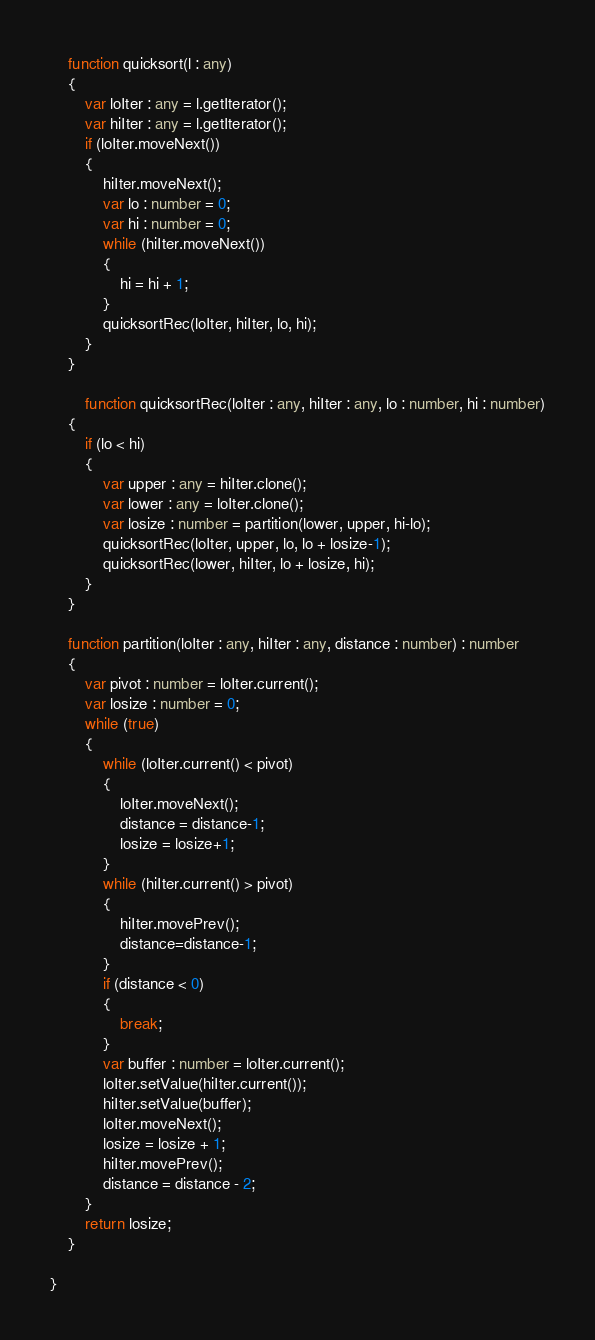<code> <loc_0><loc_0><loc_500><loc_500><_TypeScript_>	function quicksort(l : any)
	{
		var loIter : any = l.getIterator();
		var hiIter : any = l.getIterator();
		if (loIter.moveNext())
		{
			hiIter.moveNext();
			var lo : number = 0;
			var hi : number = 0;
			while (hiIter.moveNext())
			{
				hi = hi + 1;
			}
			quicksortRec(loIter, hiIter, lo, hi);
		}
	}
	
        function quicksortRec(loIter : any, hiIter : any, lo : number, hi : number)
	{
		if (lo < hi)
		{
			var upper : any = hiIter.clone();
			var lower : any = loIter.clone();
			var losize : number = partition(lower, upper, hi-lo);
			quicksortRec(loIter, upper, lo, lo + losize-1);
			quicksortRec(lower, hiIter, lo + losize, hi);
		}
	}
	
	function partition(loIter : any, hiIter : any, distance : number) : number
	{
		var pivot : number = loIter.current();
		var losize : number = 0;
		while (true)
		{
			while (loIter.current() < pivot)
			{
				loIter.moveNext();
				distance = distance-1;
				losize = losize+1;
			}
			while (hiIter.current() > pivot)
			{
				hiIter.movePrev();
				distance=distance-1;
			}
			if (distance < 0)
			{
				break;
			}
			var buffer : number = loIter.current();
			loIter.setValue(hiIter.current());
			hiIter.setValue(buffer);
			loIter.moveNext();
			losize = losize + 1;
			hiIter.movePrev();
			distance = distance - 2;
		}
		return losize;
	}

}
</code> 